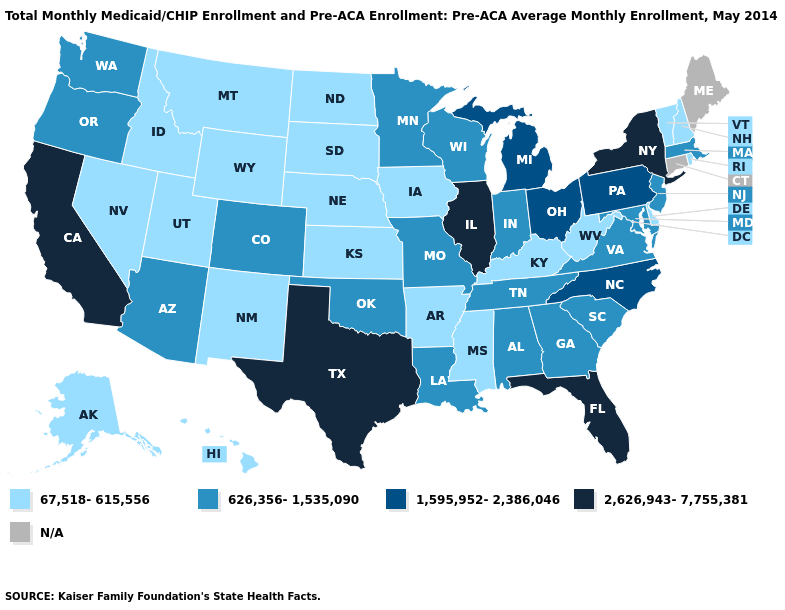Name the states that have a value in the range N/A?
Be succinct. Connecticut, Maine. Does Georgia have the lowest value in the USA?
Write a very short answer. No. What is the highest value in the USA?
Keep it brief. 2,626,943-7,755,381. What is the lowest value in states that border California?
Write a very short answer. 67,518-615,556. What is the value of Arizona?
Keep it brief. 626,356-1,535,090. Which states have the lowest value in the West?
Give a very brief answer. Alaska, Hawaii, Idaho, Montana, Nevada, New Mexico, Utah, Wyoming. What is the lowest value in the USA?
Give a very brief answer. 67,518-615,556. What is the value of Delaware?
Quick response, please. 67,518-615,556. What is the highest value in the USA?
Keep it brief. 2,626,943-7,755,381. What is the lowest value in the West?
Quick response, please. 67,518-615,556. Does Michigan have the lowest value in the MidWest?
Write a very short answer. No. Name the states that have a value in the range 1,595,952-2,386,046?
Keep it brief. Michigan, North Carolina, Ohio, Pennsylvania. Name the states that have a value in the range 626,356-1,535,090?
Give a very brief answer. Alabama, Arizona, Colorado, Georgia, Indiana, Louisiana, Maryland, Massachusetts, Minnesota, Missouri, New Jersey, Oklahoma, Oregon, South Carolina, Tennessee, Virginia, Washington, Wisconsin. What is the value of Minnesota?
Answer briefly. 626,356-1,535,090. 